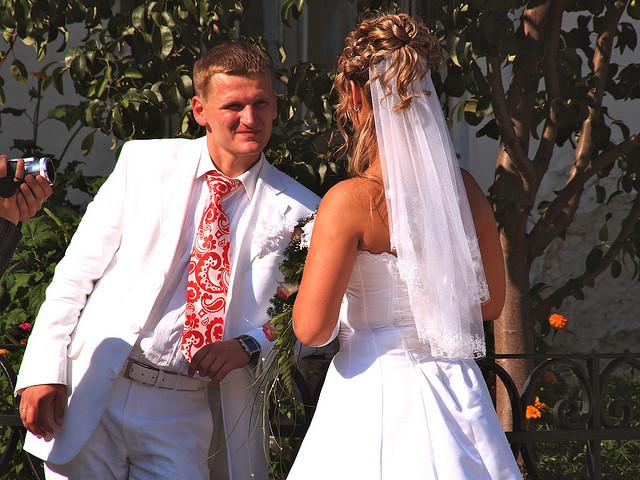What event are these people at?
Keep it brief. Wedding. What color is on his tie?
Short answer required. Red and white. Is marriage a concept created by civilization?
Short answer required. Yes. 